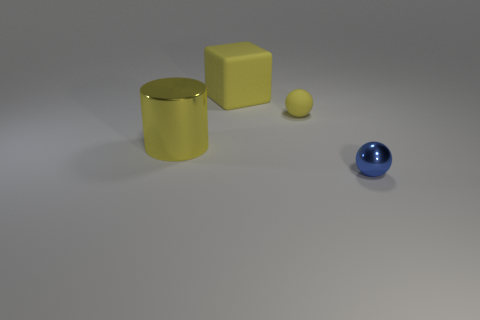What materials do the objects seem to be made of? The objects in the image give an impression of different materials. The cylinder has a reflective surface suggesting it could be made of a polished metal. The cube and small round object appear to have a matte finish, possibly resembling a plastic material, whereas the sphere seems to have a shiny, perhaps glass-like surface. Do the objects cast shadows, and what can that tell us about the light source? Yes, each object casts a shadow, indicating that there is a light source above them, slightly to the right. The firm edges of the shadows suggest that the light source is relatively close and has a high intensity, which is characteristic of a directional light like that from a spotlight. 